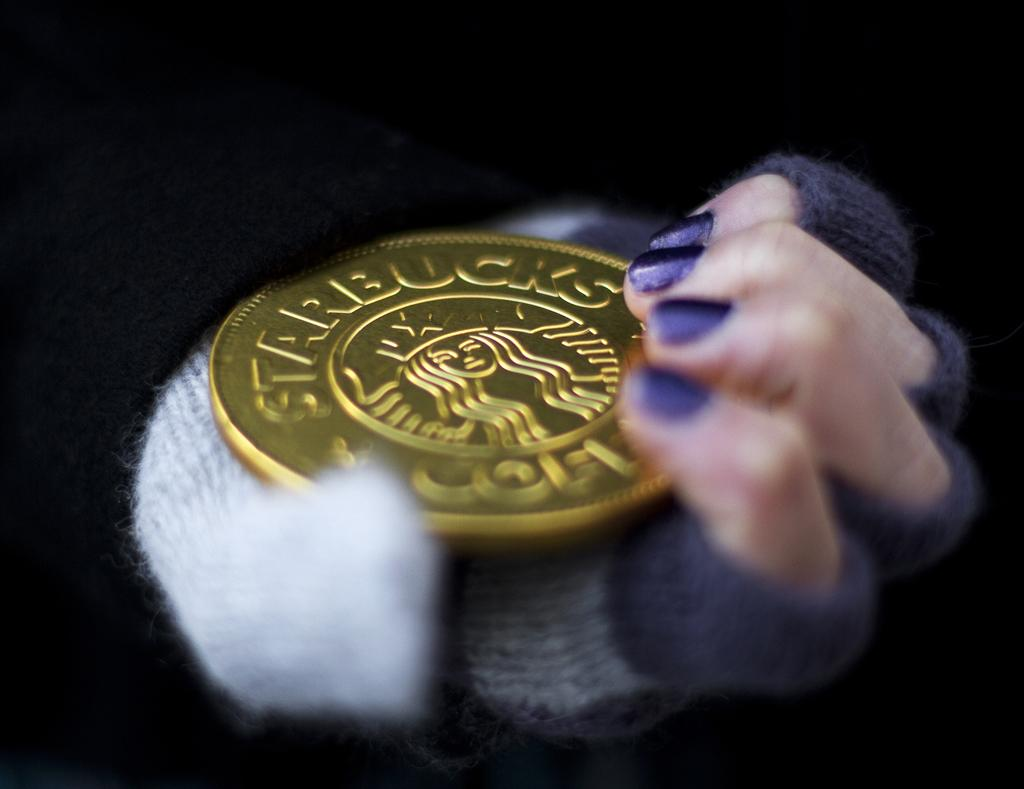<image>
Give a short and clear explanation of the subsequent image. A Starbucks gold coin in a hand with purple nail polish. 